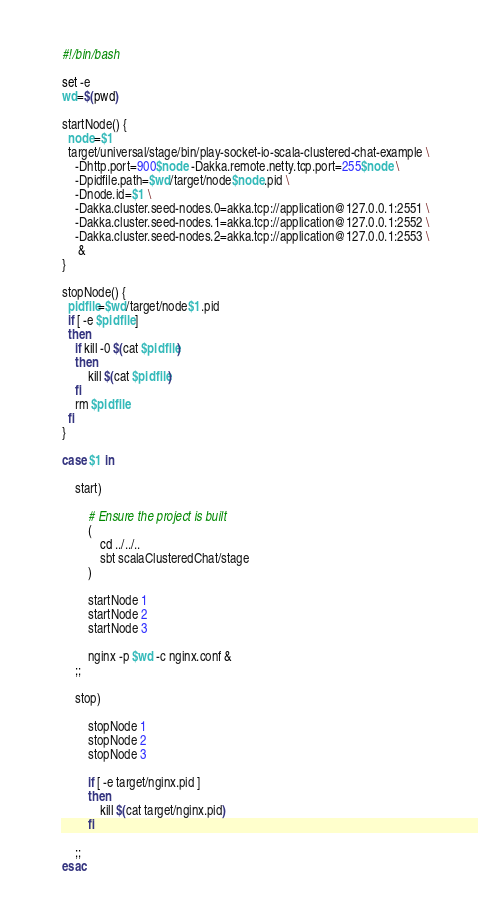<code> <loc_0><loc_0><loc_500><loc_500><_Bash_>#!/bin/bash

set -e
wd=$(pwd)

startNode() {
  node=$1
  target/universal/stage/bin/play-socket-io-scala-clustered-chat-example \
    -Dhttp.port=900$node -Dakka.remote.netty.tcp.port=255$node \
    -Dpidfile.path=$wd/target/node$node.pid \
    -Dnode.id=$1 \
    -Dakka.cluster.seed-nodes.0=akka.tcp://application@127.0.0.1:2551 \
    -Dakka.cluster.seed-nodes.1=akka.tcp://application@127.0.0.1:2552 \
    -Dakka.cluster.seed-nodes.2=akka.tcp://application@127.0.0.1:2553 \
     &
}

stopNode() {
  pidfile=$wd/target/node$1.pid
  if [ -e $pidfile ]
  then
    if kill -0 $(cat $pidfile)
    then
        kill $(cat $pidfile)
    fi
    rm $pidfile
  fi
}

case $1 in

    start)

        # Ensure the project is built
        (
            cd ../../..
            sbt scalaClusteredChat/stage
        )

        startNode 1
        startNode 2
        startNode 3

        nginx -p $wd -c nginx.conf &
    ;;

    stop)

        stopNode 1
        stopNode 2
        stopNode 3

        if [ -e target/nginx.pid ]
        then
            kill $(cat target/nginx.pid)
        fi

    ;;
esac
</code> 